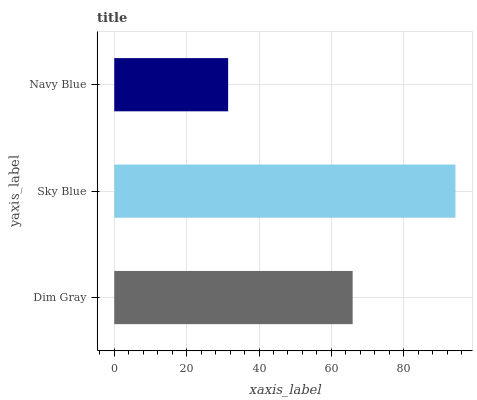Is Navy Blue the minimum?
Answer yes or no. Yes. Is Sky Blue the maximum?
Answer yes or no. Yes. Is Sky Blue the minimum?
Answer yes or no. No. Is Navy Blue the maximum?
Answer yes or no. No. Is Sky Blue greater than Navy Blue?
Answer yes or no. Yes. Is Navy Blue less than Sky Blue?
Answer yes or no. Yes. Is Navy Blue greater than Sky Blue?
Answer yes or no. No. Is Sky Blue less than Navy Blue?
Answer yes or no. No. Is Dim Gray the high median?
Answer yes or no. Yes. Is Dim Gray the low median?
Answer yes or no. Yes. Is Navy Blue the high median?
Answer yes or no. No. Is Navy Blue the low median?
Answer yes or no. No. 